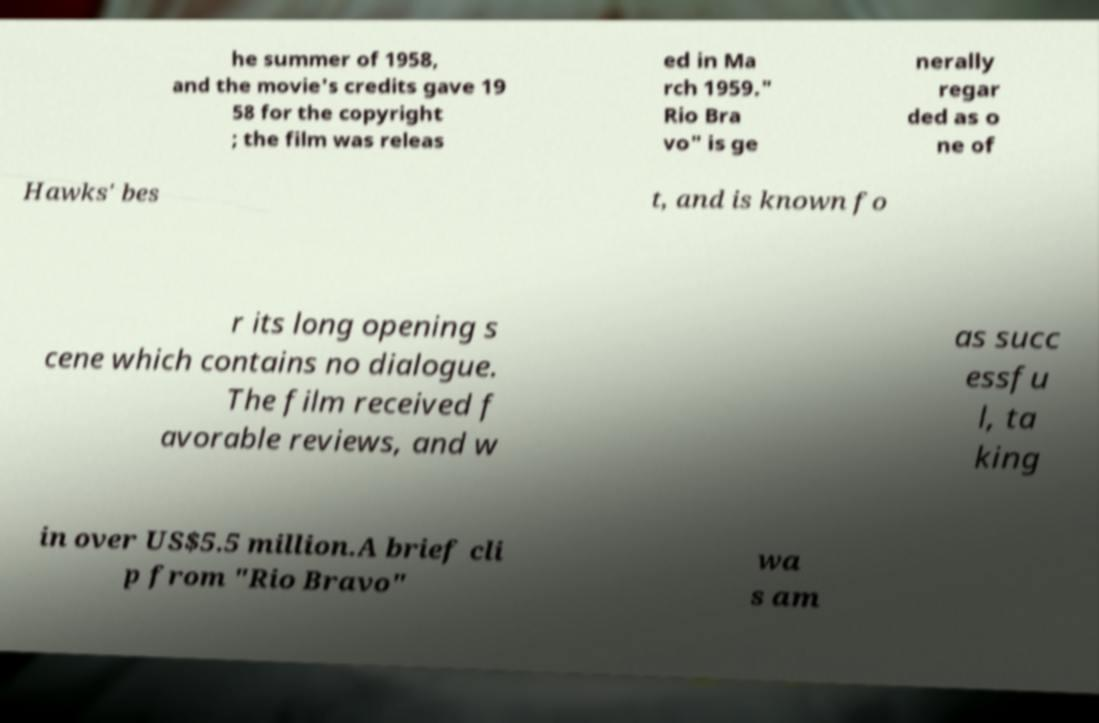Could you assist in decoding the text presented in this image and type it out clearly? he summer of 1958, and the movie's credits gave 19 58 for the copyright ; the film was releas ed in Ma rch 1959." Rio Bra vo" is ge nerally regar ded as o ne of Hawks' bes t, and is known fo r its long opening s cene which contains no dialogue. The film received f avorable reviews, and w as succ essfu l, ta king in over US$5.5 million.A brief cli p from "Rio Bravo" wa s am 